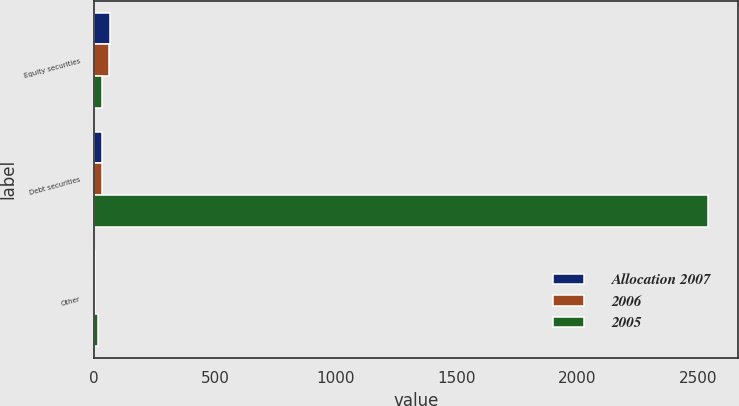Convert chart. <chart><loc_0><loc_0><loc_500><loc_500><stacked_bar_chart><ecel><fcel>Equity securities<fcel>Debt securities<fcel>Other<nl><fcel>Allocation 2007<fcel>66<fcel>31<fcel>3<nl><fcel>2006<fcel>63<fcel>33<fcel>4<nl><fcel>2005<fcel>32<fcel>2540<fcel>15<nl></chart> 